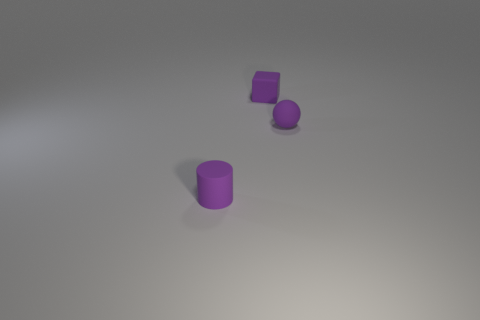Add 3 large purple matte balls. How many objects exist? 6 Subtract all balls. How many objects are left? 2 Add 1 tiny purple rubber cylinders. How many tiny purple rubber cylinders are left? 2 Add 1 purple spheres. How many purple spheres exist? 2 Subtract 1 purple cylinders. How many objects are left? 2 Subtract all tiny purple matte things. Subtract all big green metallic blocks. How many objects are left? 0 